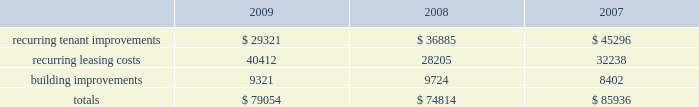34| | duke realty corporation annual report 2009 property investment we evaluate development and acquisition opportunities based upon market outlook , supply and long-term growth potential .
Our ability to make future property investments is dependent upon our continued access to our longer-term sources of liquidity including the issuances of debt or equity securities as well as generating cash flow by disposing of selected properties .
In light of current economic conditions , management continues to evaluate our investment priorities and is focused on accretive growth .
We have continued to operate at a substantially reduced level of new development activity , as compared to recent years , and are focused on the core operations of our existing base of properties .
Recurring expenditures one of our principal uses of our liquidity is to fund the recurring leasing/capital expenditures of our real estate investments .
The following is a summary of our recurring capital expenditures for the years ended december 31 , 2009 , 2008 and 2007 , respectively ( in thousands ) : dividends and distributions we are required to meet the distribution requirements of the internal revenue code of 1986 , as amended ( the 201ccode 201d ) , in order to maintain our reit status .
Because depreciation and impairments are non-cash expenses , cash flow will typically be greater than operating income .
We paid dividends per share of $ 0.76 , $ 1.93 and $ 1.91 for the years ended december 31 , 2009 , 2008 and 2007 , respectively .
We expect to continue to distribute at least an amount equal to our taxable earnings , to meet the requirements to maintain our reit status , and additional amounts as determined by our board of directors .
Distributions are declared at the discretion of our board of directors and are subject to actual cash available for distribution , our financial condition , capital requirements and such other factors as our board of directors deems relevant .
At december 31 , 2009 we had six series of preferred shares outstanding .
The annual dividend rates on our preferred shares range between 6.5% ( 6.5 % ) and 8.375% ( 8.375 % ) and are paid in arrears quarterly. .

What was the percent of the increase in the dividend from 2007 to 2008? 
Computations: ((1.93 - 1.91) / 1.91)
Answer: 0.01047. 